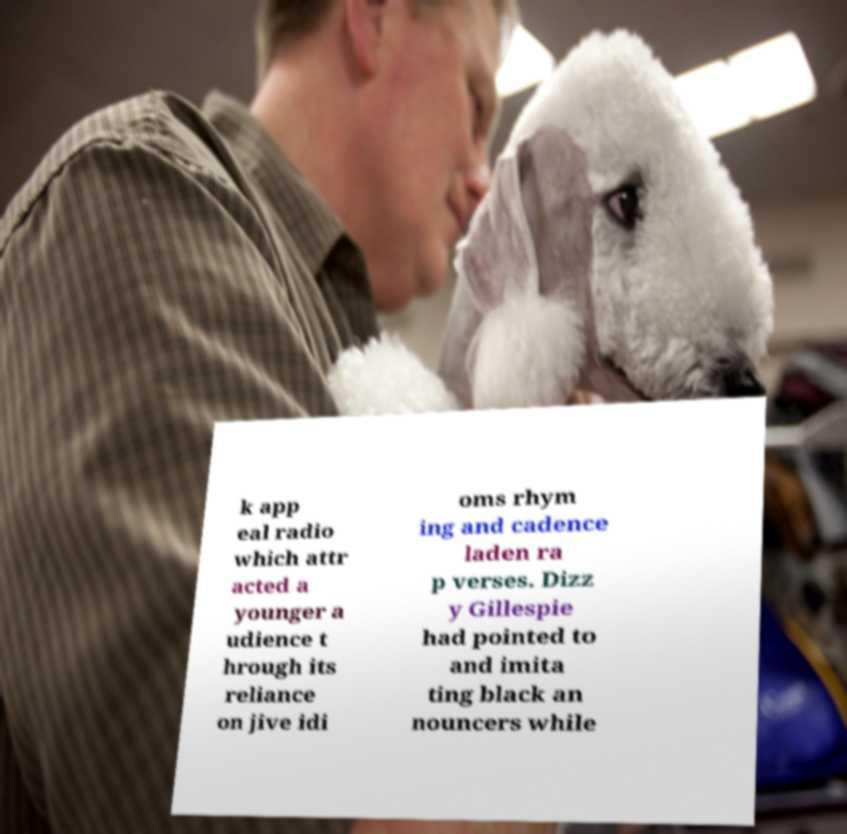For documentation purposes, I need the text within this image transcribed. Could you provide that? k app eal radio which attr acted a younger a udience t hrough its reliance on jive idi oms rhym ing and cadence laden ra p verses. Dizz y Gillespie had pointed to and imita ting black an nouncers while 